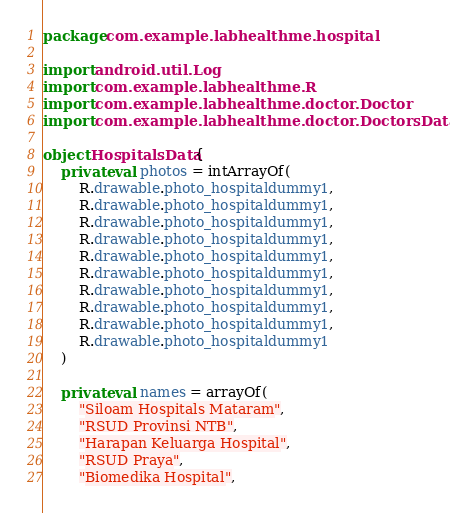Convert code to text. <code><loc_0><loc_0><loc_500><loc_500><_Kotlin_>package com.example.labhealthme.hospital

import android.util.Log
import com.example.labhealthme.R
import com.example.labhealthme.doctor.Doctor
import com.example.labhealthme.doctor.DoctorsData

object HospitalsData {
    private val photos = intArrayOf(
        R.drawable.photo_hospitaldummy1,
        R.drawable.photo_hospitaldummy1,
        R.drawable.photo_hospitaldummy1,
        R.drawable.photo_hospitaldummy1,
        R.drawable.photo_hospitaldummy1,
        R.drawable.photo_hospitaldummy1,
        R.drawable.photo_hospitaldummy1,
        R.drawable.photo_hospitaldummy1,
        R.drawable.photo_hospitaldummy1,
        R.drawable.photo_hospitaldummy1
    )

    private val names = arrayOf(
        "Siloam Hospitals Mataram",
        "RSUD Provinsi NTB",
        "Harapan Keluarga Hospital",
        "RSUD Praya",
        "Biomedika Hospital",</code> 